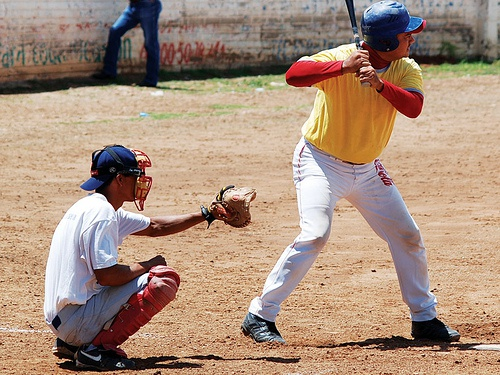Describe the objects in this image and their specific colors. I can see people in lightgray, red, white, darkgray, and black tones, people in lightgray, white, black, maroon, and gray tones, people in lightgray, black, navy, gray, and maroon tones, baseball glove in lightgray, maroon, black, and tan tones, and baseball bat in lightgray, black, navy, gray, and darkgray tones in this image. 